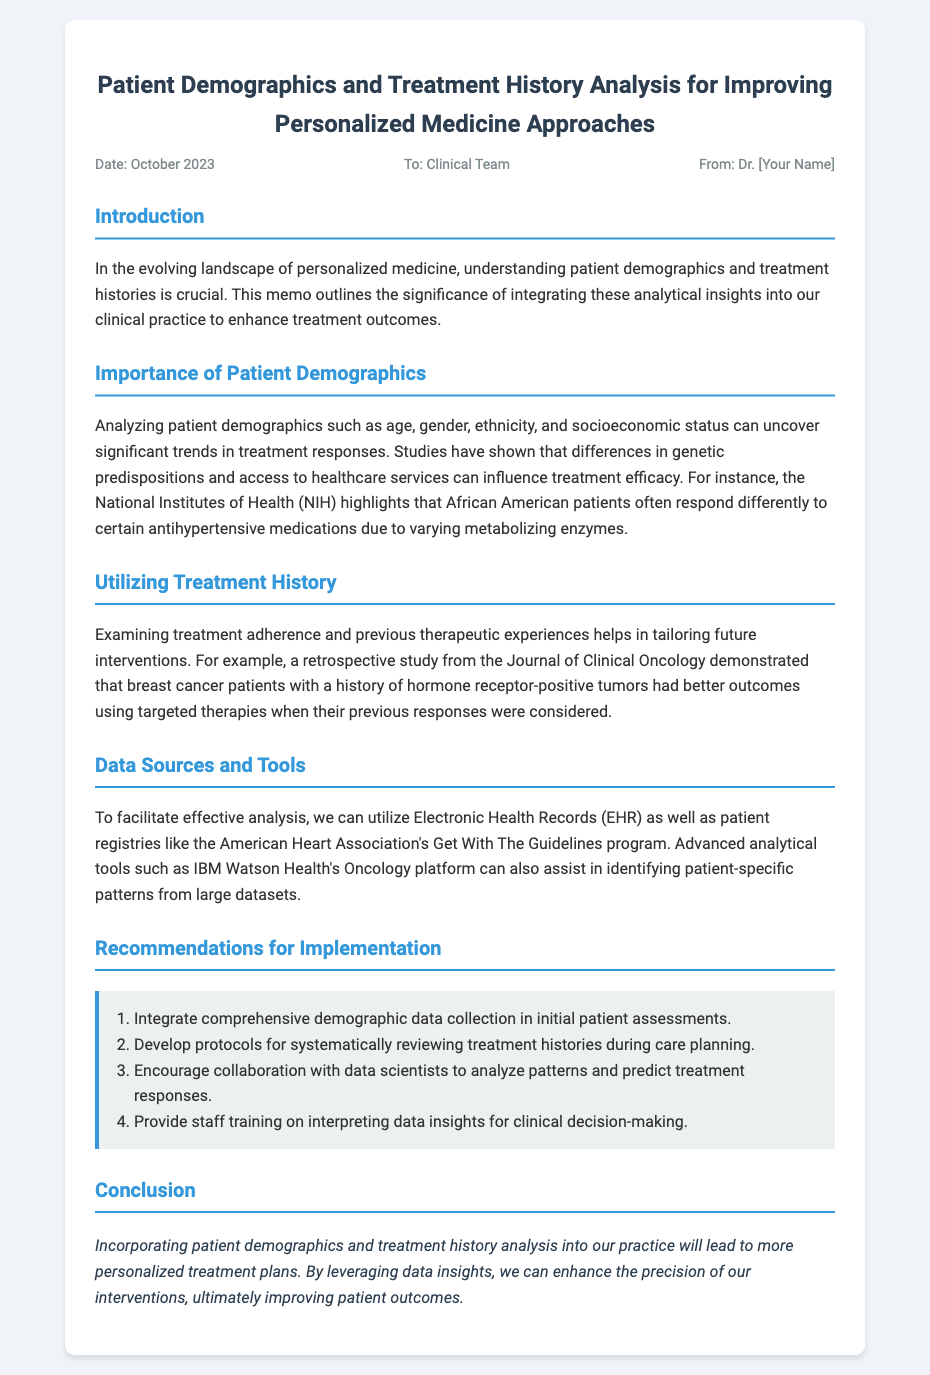what is the title of the memo? The title appears at the top of the document, summarizing the content focus.
Answer: Patient Demographics and Treatment History Analysis for Improving Personalized Medicine Approaches who is the memo addressed to? The document specifies the intended audience in the meta section.
Answer: Clinical Team what is the date of the memo? The memo includes the date in the meta section for reference.
Answer: October 2023 which agencies are mentioned as data sources? The memo lists institutions that provide important data for analysis.
Answer: National Institutes of Health and American Heart Association what demographic aspects are highlighted as important? The document discusses specific demographic factors related to treatment outcomes.
Answer: age, gender, ethnicity, and socioeconomic status what is the purpose of analyzing treatment history? The memo talks about the significance of reviewing past treatments for future care planning.
Answer: Tailoring future interventions how many recommendations are listed for implementation? The number of suggestions can be counted from the recommendations section.
Answer: Four what is emphasized in the conclusion? The message is summarized at the end, encapsulating the overall aim of the memo.
Answer: More personalized treatment plans what is an example of a tool mentioned for analysis? The document provides examples of advanced tools for conducting data analysis.
Answer: IBM Watson Health's Oncology platform 